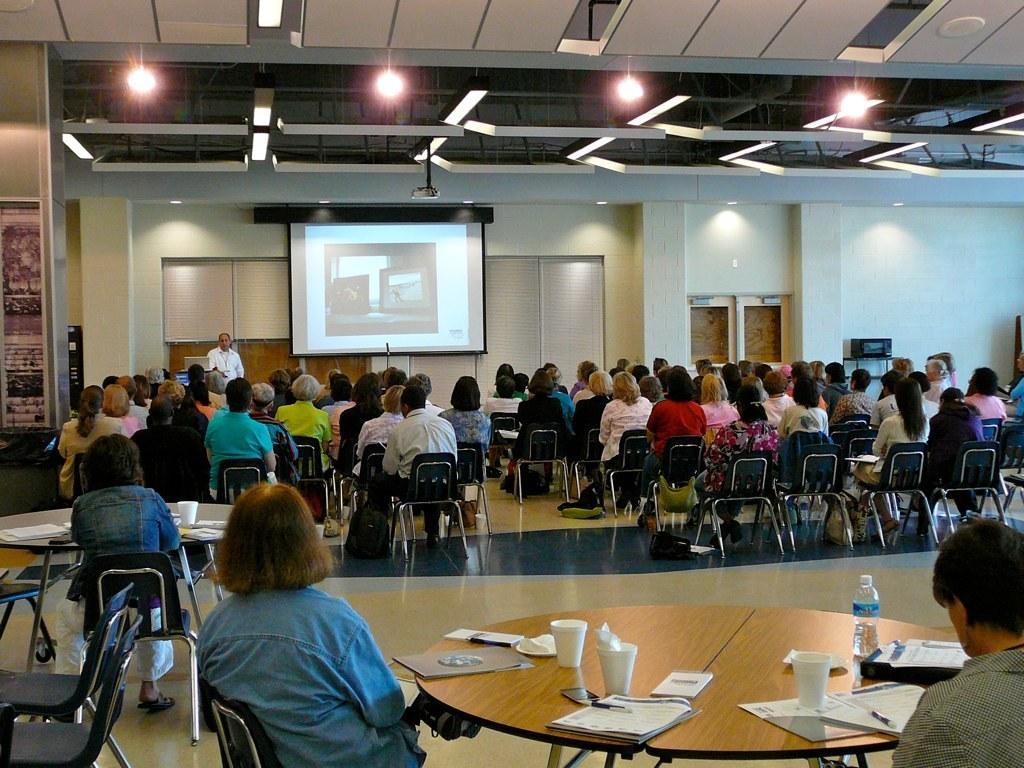Describe this image in one or two sentences. In the picture we can see a group of people sitting on the chairs and some people sitting back near the table and on the table we can see glasses, papers, pens and bottle. In the background we can see a screen on the wall and to the ceiling we can see the projector and lights. 